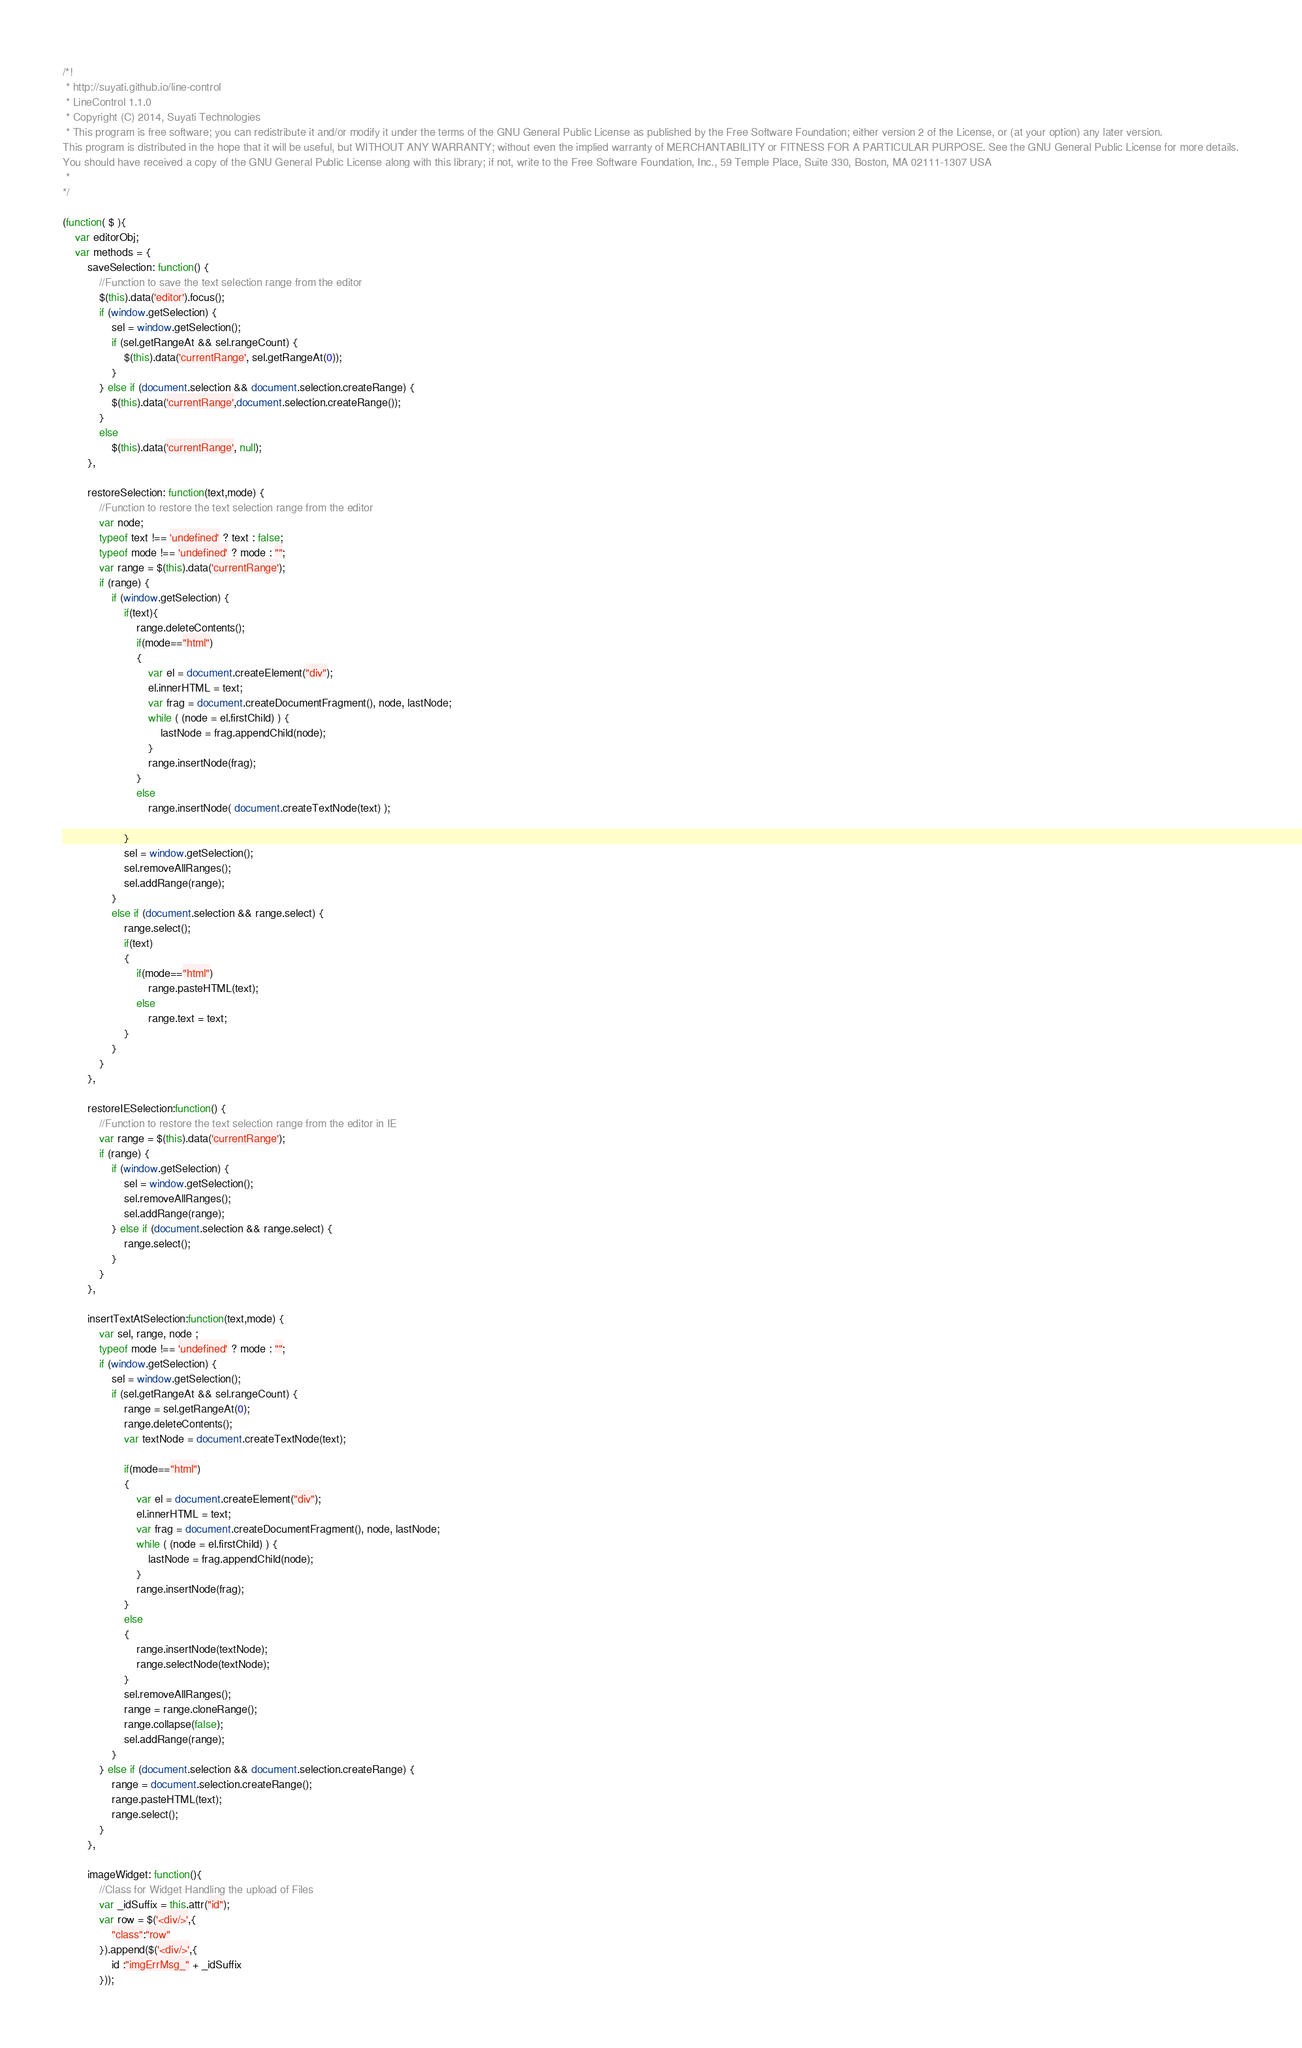Convert code to text. <code><loc_0><loc_0><loc_500><loc_500><_JavaScript_>/*!
 * http://suyati.github.io/line-control
 * LineControl 1.1.0
 * Copyright (C) 2014, Suyati Technologies
 * This program is free software; you can redistribute it and/or modify it under the terms of the GNU General Public License as published by the Free Software Foundation; either version 2 of the License, or (at your option) any later version.
This program is distributed in the hope that it will be useful, but WITHOUT ANY WARRANTY; without even the implied warranty of MERCHANTABILITY or FITNESS FOR A PARTICULAR PURPOSE. See the GNU General Public License for more details.
You should have received a copy of the GNU General Public License along with this library; if not, write to the Free Software Foundation, Inc., 59 Temple Place, Suite 330, Boston, MA 02111-1307 USA
 *
*/

(function( $ ){
	var editorObj;
	var methods = {
		saveSelection: function() {
			//Function to save the text selection range from the editor
			$(this).data('editor').focus();
		    if (window.getSelection) {
		        sel = window.getSelection();
		        if (sel.getRangeAt && sel.rangeCount) {
		            $(this).data('currentRange', sel.getRangeAt(0));
		        }
		    } else if (document.selection && document.selection.createRange) {
		        $(this).data('currentRange',document.selection.createRange());
		    }
		    else
		    	$(this).data('currentRange', null);
		},

		restoreSelection: function(text,mode) {
			//Function to restore the text selection range from the editor
			var node;
			typeof text !== 'undefined' ? text : false;
			typeof mode !== 'undefined' ? mode : "";
			var range = $(this).data('currentRange');
		    if (range) {
		        if (window.getSelection) {
		        	if(text){
		            	range.deleteContents();
		            	if(mode=="html")
	            		{
    			            var el = document.createElement("div");
				            el.innerHTML = text;
				            var frag = document.createDocumentFragment(), node, lastNode;
				            while ( (node = el.firstChild) ) {
				                lastNode = frag.appendChild(node);
				            }
				            range.insertNode(frag);
	            		}
		            	else
            				range.insertNode( document.createTextNode(text) );

		            }
		            sel = window.getSelection();
		            sel.removeAllRanges();
		            sel.addRange(range);		            
		        }
		        else if (document.selection && range.select) {
		            range.select();
		            if(text)
		            {
		            	if(mode=="html")
		            		range.pasteHTML(text);
		            	else
		            		range.text = text;
		            }
		        }
		    }
		},

		restoreIESelection:function() {
			//Function to restore the text selection range from the editor in IE
			var range = $(this).data('currentRange');
		    if (range) {
		        if (window.getSelection) {
		            sel = window.getSelection();
		            sel.removeAllRanges();
		            sel.addRange(range);
		        } else if (document.selection && range.select) {
		            range.select();
		        }
		    }
		},

		insertTextAtSelection:function(text,mode) {
		    var sel, range, node ;
		    typeof mode !== 'undefined' ? mode : "";
		    if (window.getSelection) {
		        sel = window.getSelection();
		        if (sel.getRangeAt && sel.rangeCount) {
		            range = sel.getRangeAt(0);
		            range.deleteContents();
		            var textNode = document.createTextNode(text); 
		            
		            if(mode=="html")
		            { 
		                var el = document.createElement("div");
		                el.innerHTML = text;
		                var frag = document.createDocumentFragment(), node, lastNode;
		                while ( (node = el.firstChild) ) {
		                    lastNode = frag.appendChild(node);
		                }
		                range.insertNode(frag);
		            }
		            else
		            { 
		            	range.insertNode(textNode);
		            	range.selectNode(textNode);
		            }
		            sel.removeAllRanges();
		            range = range.cloneRange();		            
		            range.collapse(false);
		            sel.addRange(range);
		        }
		    } else if (document.selection && document.selection.createRange) { 
		        range = document.selection.createRange();
		        range.pasteHTML(text);
		        range.select();
		    }
		},

		imageWidget: function(){
			//Class for Widget Handling the upload of Files
			var _idSuffix = this.attr("id");
			var row = $('<div/>',{
				"class":"row"
			}).append($('<div/>',{
				id :"imgErrMsg_" + _idSuffix
			}));</code> 